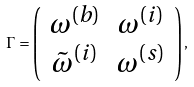Convert formula to latex. <formula><loc_0><loc_0><loc_500><loc_500>\Gamma = \left ( \begin{array} { c c } \omega ^ { ( b ) } & \omega ^ { ( i ) } \\ \tilde { \omega } ^ { ( i ) } & \omega ^ { ( s ) } \\ \end{array} \right ) ,</formula> 